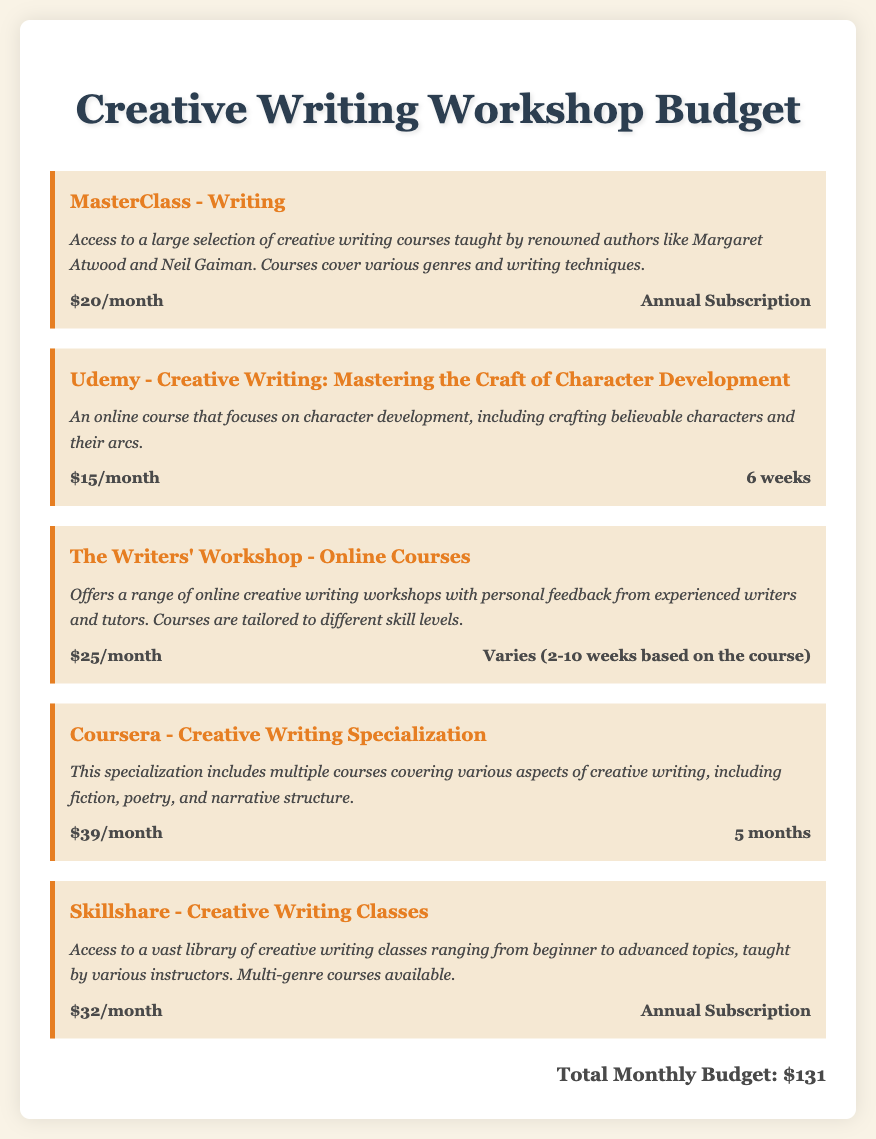What is the cost of MasterClass - Writing? The document specifies that the cost of MasterClass - Writing is $20 per month.
Answer: $20/month What is the duration of the Udemy course? The document states that the Udemy course lasts for 6 weeks.
Answer: 6 weeks How many months does the Coursera specialization last? The document indicates that the Coursera specialization duration is 5 months.
Answer: 5 months What is the total monthly budget listed for the workshops? The document sums up the costs and mentions a total monthly budget of $131.
Answer: $131 What type of feedback does The Writers' Workshop offer? The document describes that The Writers' Workshop provides personal feedback from experienced writers and tutors.
Answer: Personal feedback What is the cost of Skillshare subscription? The document states that the cost of the Skillshare subscription is $32 per month.
Answer: $32/month How many courses does the Coursera specialization cover? The document mentions that the specialization includes multiple courses covering various aspects of creative writing.
Answer: Multiple courses What kind of courses does Udemy focus on? The document specifies that Udemy focuses on character development in creative writing.
Answer: Character development What is a unique feature of Skillshare's offerings? The document states that Skillshare provides access to a vast library of creative writing classes.
Answer: Vast library of classes 